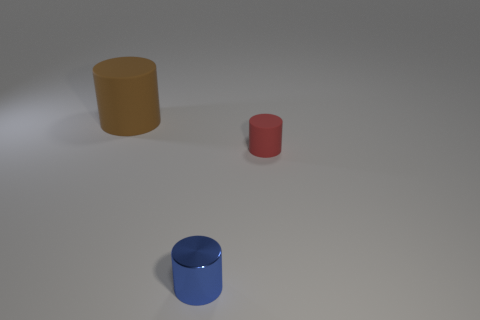There is a matte thing on the left side of the blue shiny thing; is its size the same as the tiny red thing?
Offer a very short reply. No. Are there more brown cylinders behind the small blue object than brown matte cylinders left of the big brown object?
Provide a succinct answer. Yes. There is a object that is in front of the brown object and behind the small blue cylinder; what shape is it?
Provide a short and direct response. Cylinder. The rubber thing on the right side of the big brown matte cylinder has what shape?
Provide a short and direct response. Cylinder. How big is the matte cylinder that is left of the small cylinder that is to the right of the tiny object in front of the red rubber cylinder?
Your response must be concise. Large. Do the tiny metallic object and the large thing have the same shape?
Your answer should be compact. Yes. There is a object that is both left of the tiny red object and right of the large brown cylinder; what size is it?
Make the answer very short. Small. There is another tiny blue thing that is the same shape as the small rubber object; what is it made of?
Provide a succinct answer. Metal. What is the material of the thing in front of the matte thing in front of the large brown matte cylinder?
Provide a short and direct response. Metal. There is a tiny blue thing; does it have the same shape as the matte thing on the left side of the blue metal cylinder?
Your response must be concise. Yes. 